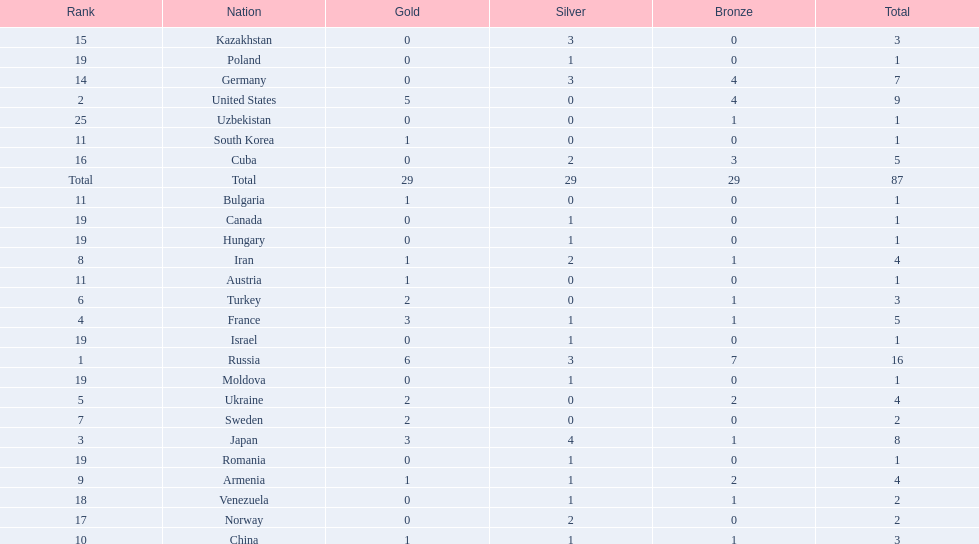What nations have one gold medal? Iran, Armenia, China, Austria, Bulgaria, South Korea. Of these, which nations have zero silver medals? Austria, Bulgaria, South Korea. Of these, which nations also have zero bronze medals? Austria. 